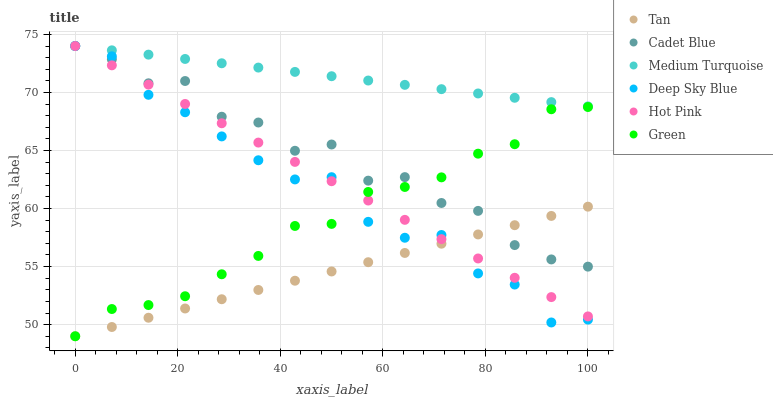Does Tan have the minimum area under the curve?
Answer yes or no. Yes. Does Medium Turquoise have the maximum area under the curve?
Answer yes or no. Yes. Does Hot Pink have the minimum area under the curve?
Answer yes or no. No. Does Hot Pink have the maximum area under the curve?
Answer yes or no. No. Is Tan the smoothest?
Answer yes or no. Yes. Is Cadet Blue the roughest?
Answer yes or no. Yes. Is Medium Turquoise the smoothest?
Answer yes or no. No. Is Medium Turquoise the roughest?
Answer yes or no. No. Does Green have the lowest value?
Answer yes or no. Yes. Does Hot Pink have the lowest value?
Answer yes or no. No. Does Deep Sky Blue have the highest value?
Answer yes or no. Yes. Does Green have the highest value?
Answer yes or no. No. Is Green less than Medium Turquoise?
Answer yes or no. Yes. Is Medium Turquoise greater than Green?
Answer yes or no. Yes. Does Cadet Blue intersect Green?
Answer yes or no. Yes. Is Cadet Blue less than Green?
Answer yes or no. No. Is Cadet Blue greater than Green?
Answer yes or no. No. Does Green intersect Medium Turquoise?
Answer yes or no. No. 